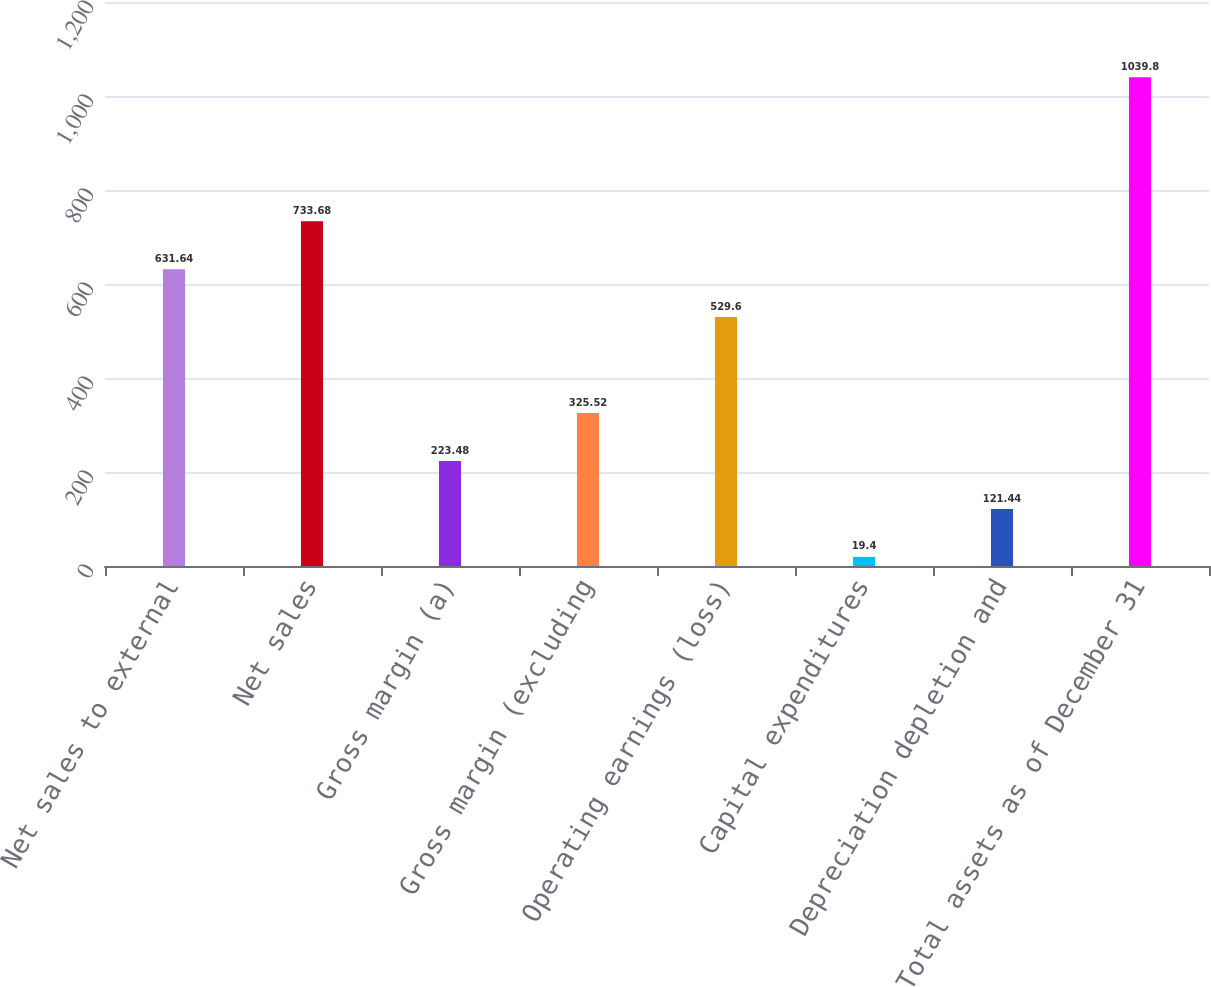<chart> <loc_0><loc_0><loc_500><loc_500><bar_chart><fcel>Net sales to external<fcel>Net sales<fcel>Gross margin (a)<fcel>Gross margin (excluding<fcel>Operating earnings (loss)<fcel>Capital expenditures<fcel>Depreciation depletion and<fcel>Total assets as of December 31<nl><fcel>631.64<fcel>733.68<fcel>223.48<fcel>325.52<fcel>529.6<fcel>19.4<fcel>121.44<fcel>1039.8<nl></chart> 